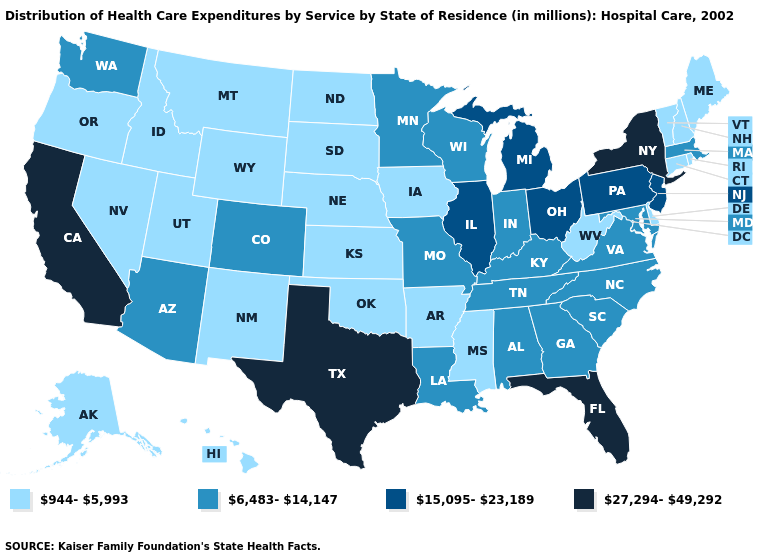Does Alabama have a higher value than Alaska?
Quick response, please. Yes. What is the lowest value in the USA?
Concise answer only. 944-5,993. Name the states that have a value in the range 6,483-14,147?
Give a very brief answer. Alabama, Arizona, Colorado, Georgia, Indiana, Kentucky, Louisiana, Maryland, Massachusetts, Minnesota, Missouri, North Carolina, South Carolina, Tennessee, Virginia, Washington, Wisconsin. What is the value of Colorado?
Answer briefly. 6,483-14,147. What is the highest value in the USA?
Be succinct. 27,294-49,292. Does California have the lowest value in the West?
Give a very brief answer. No. Does Nebraska have the lowest value in the MidWest?
Answer briefly. Yes. What is the value of Tennessee?
Short answer required. 6,483-14,147. What is the value of Louisiana?
Give a very brief answer. 6,483-14,147. Among the states that border Kansas , which have the highest value?
Write a very short answer. Colorado, Missouri. Which states have the lowest value in the South?
Quick response, please. Arkansas, Delaware, Mississippi, Oklahoma, West Virginia. What is the lowest value in the West?
Write a very short answer. 944-5,993. Does Utah have the same value as Idaho?
Short answer required. Yes. Name the states that have a value in the range 27,294-49,292?
Short answer required. California, Florida, New York, Texas. What is the lowest value in the USA?
Quick response, please. 944-5,993. 